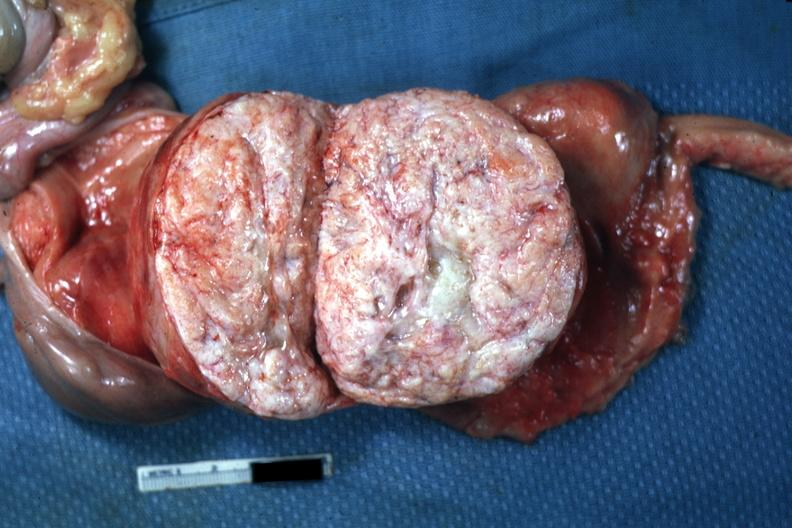s leiomyoma present?
Answer the question using a single word or phrase. Yes 